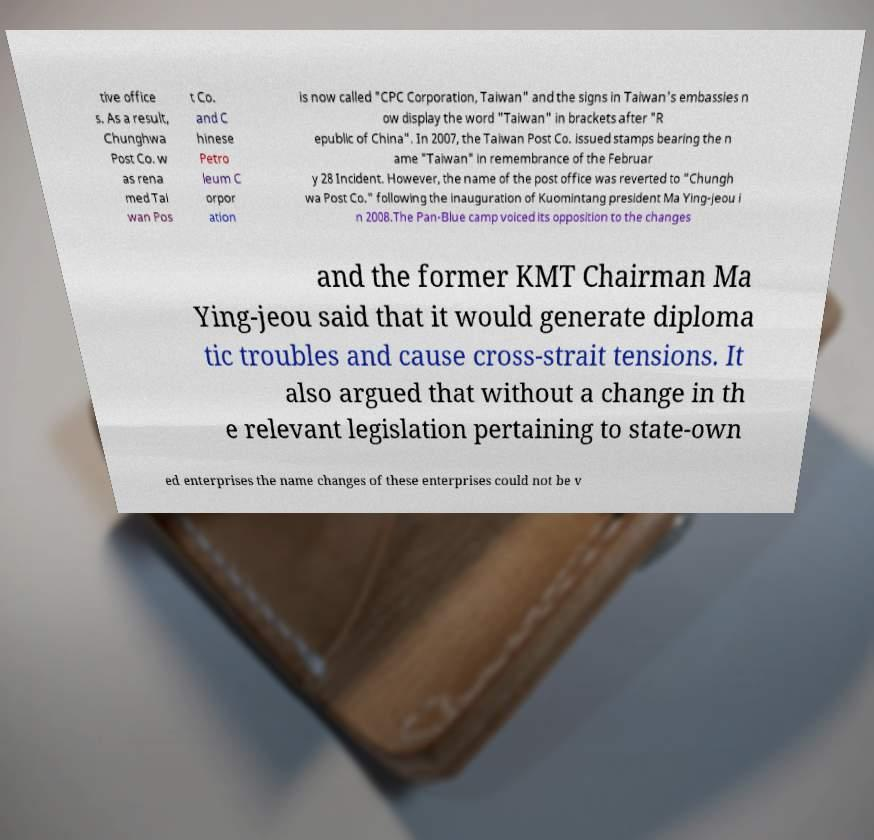Could you assist in decoding the text presented in this image and type it out clearly? tive office s. As a result, Chunghwa Post Co. w as rena med Tai wan Pos t Co. and C hinese Petro leum C orpor ation is now called "CPC Corporation, Taiwan" and the signs in Taiwan's embassies n ow display the word "Taiwan" in brackets after "R epublic of China". In 2007, the Taiwan Post Co. issued stamps bearing the n ame "Taiwan" in remembrance of the Februar y 28 Incident. However, the name of the post office was reverted to "Chungh wa Post Co." following the inauguration of Kuomintang president Ma Ying-jeou i n 2008.The Pan-Blue camp voiced its opposition to the changes and the former KMT Chairman Ma Ying-jeou said that it would generate diploma tic troubles and cause cross-strait tensions. It also argued that without a change in th e relevant legislation pertaining to state-own ed enterprises the name changes of these enterprises could not be v 